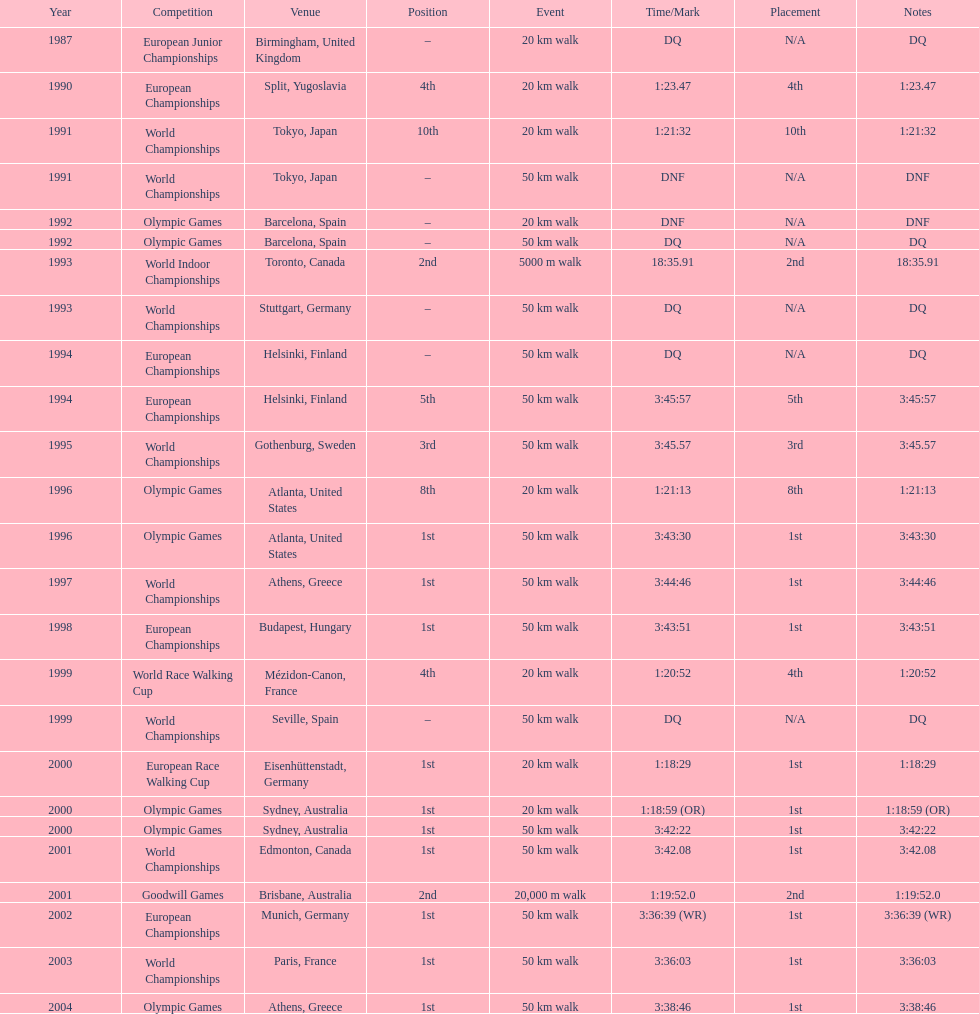How many instances was the top spot indicated as the position? 10. 